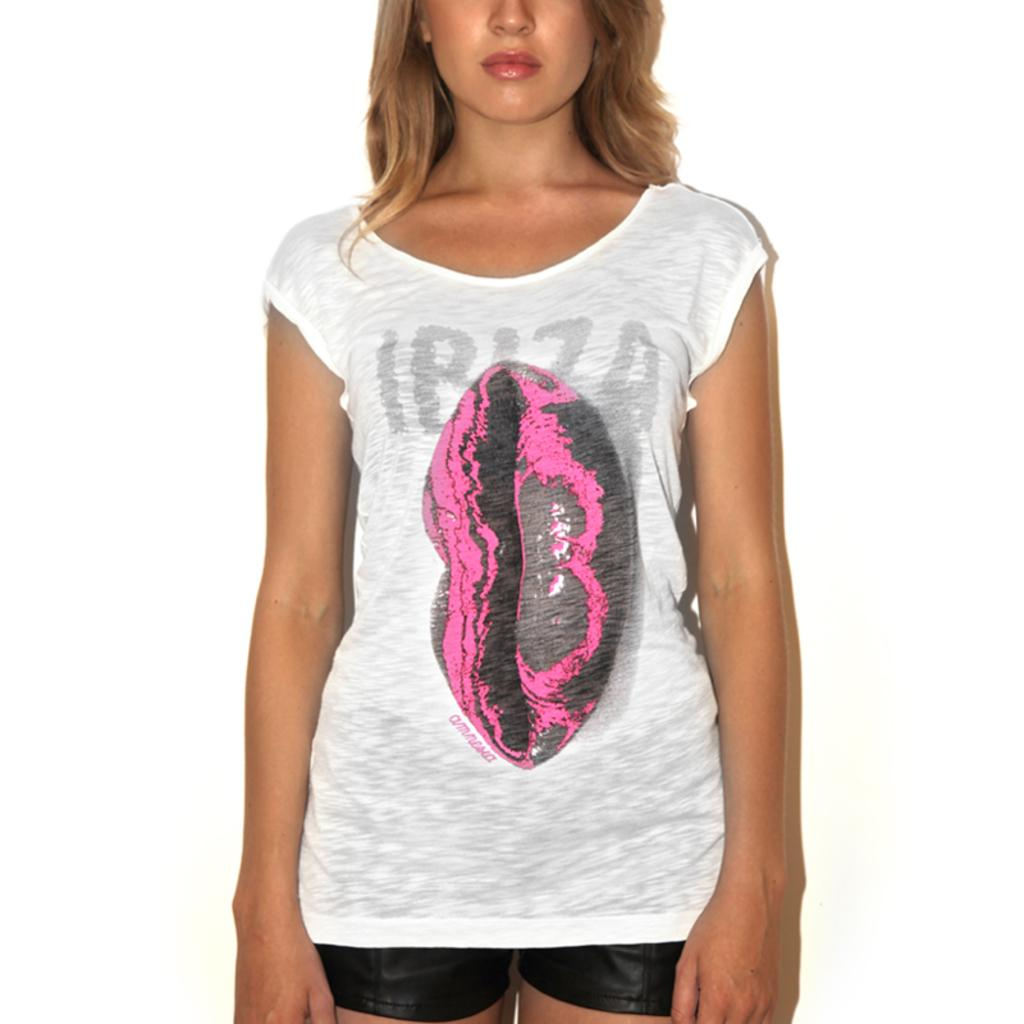What is the main subject of the image? There is a woman standing in the image. What can be seen in the background of the image? The background of the image is white. How many giants are present in the image? There are no giants present in the image; it features a woman standing in front of a white background. What type of cover is on the woman in the image? There is no cover on the woman in the image; she is not wearing any clothing or accessories that could be considered a cover. 